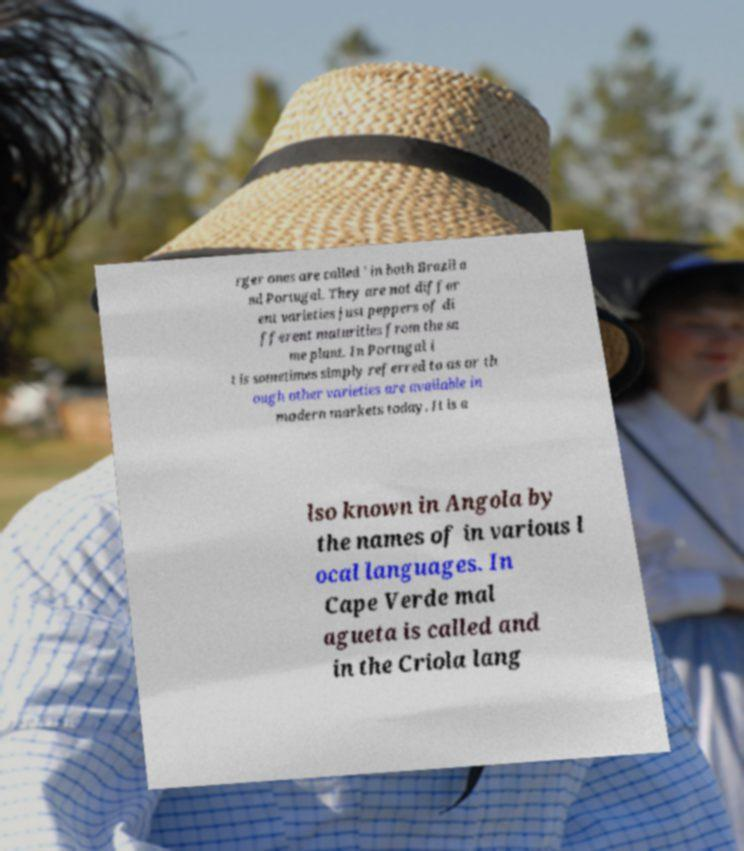Can you accurately transcribe the text from the provided image for me? rger ones are called ' in both Brazil a nd Portugal. They are not differ ent varieties just peppers of di fferent maturities from the sa me plant. In Portugal i t is sometimes simply referred to as or th ough other varieties are available in modern markets today. It is a lso known in Angola by the names of in various l ocal languages. In Cape Verde mal agueta is called and in the Criola lang 